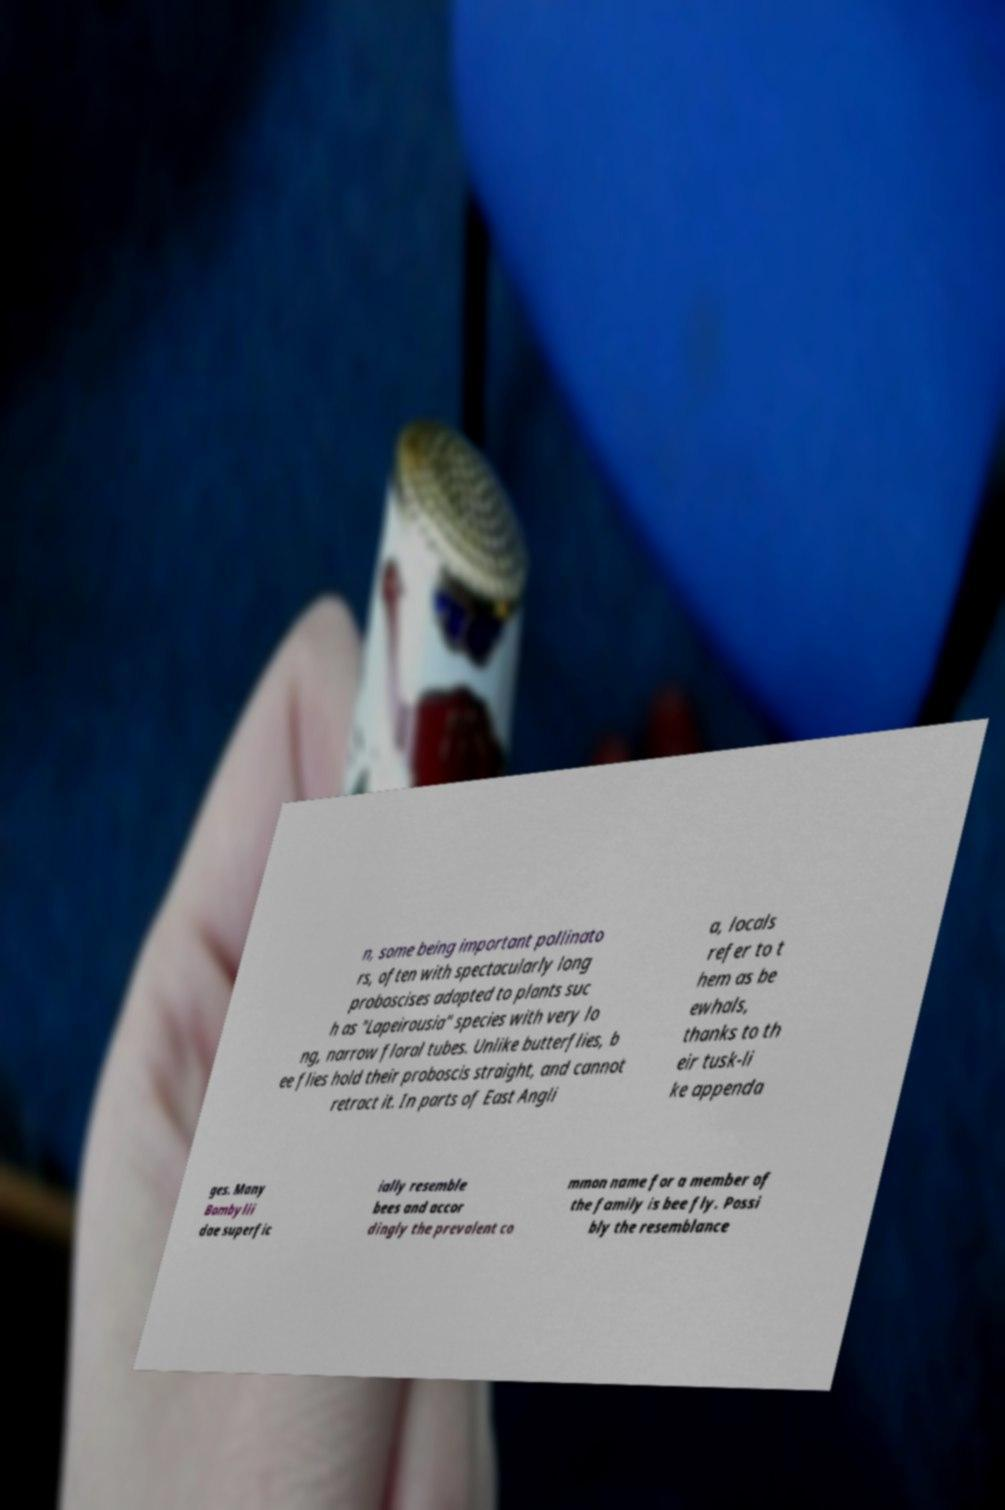Can you accurately transcribe the text from the provided image for me? n, some being important pollinato rs, often with spectacularly long proboscises adapted to plants suc h as "Lapeirousia" species with very lo ng, narrow floral tubes. Unlike butterflies, b ee flies hold their proboscis straight, and cannot retract it. In parts of East Angli a, locals refer to t hem as be ewhals, thanks to th eir tusk-li ke appenda ges. Many Bombylii dae superfic ially resemble bees and accor dingly the prevalent co mmon name for a member of the family is bee fly. Possi bly the resemblance 